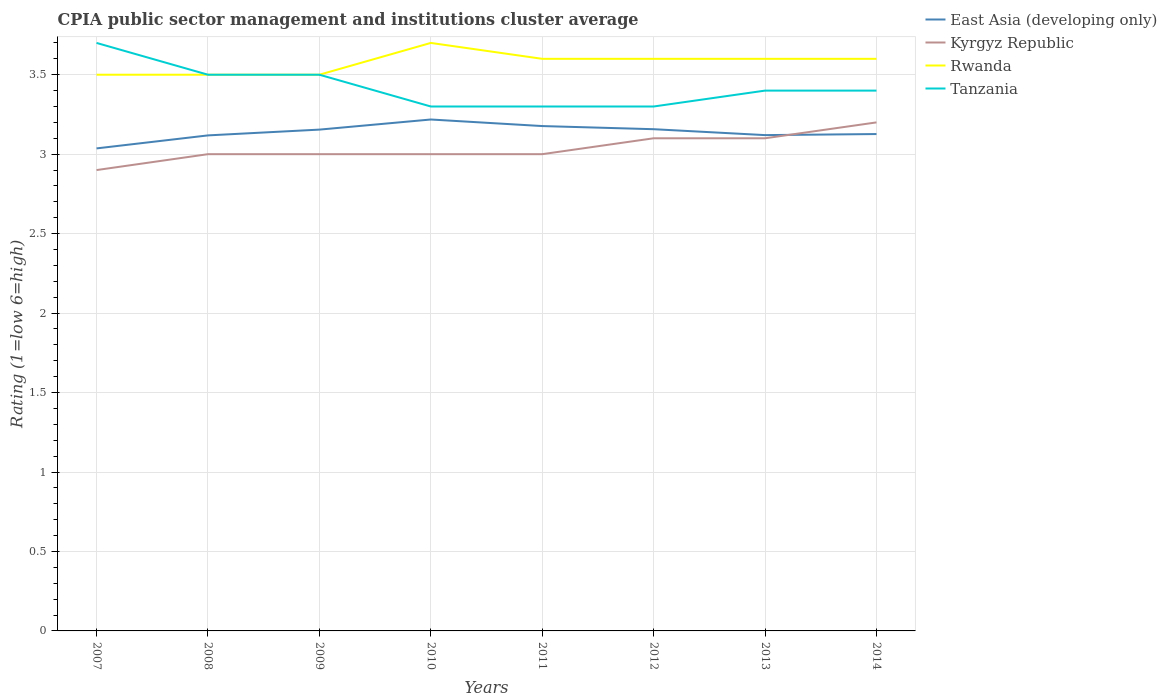Across all years, what is the maximum CPIA rating in Kyrgyz Republic?
Provide a short and direct response. 2.9. What is the total CPIA rating in Rwanda in the graph?
Offer a terse response. -0.1. What is the difference between the highest and the second highest CPIA rating in Rwanda?
Provide a short and direct response. 0.2. Is the CPIA rating in Tanzania strictly greater than the CPIA rating in Rwanda over the years?
Offer a very short reply. No. How many years are there in the graph?
Provide a succinct answer. 8. Are the values on the major ticks of Y-axis written in scientific E-notation?
Offer a terse response. No. Does the graph contain any zero values?
Your response must be concise. No. Does the graph contain grids?
Offer a terse response. Yes. How many legend labels are there?
Your answer should be very brief. 4. What is the title of the graph?
Ensure brevity in your answer.  CPIA public sector management and institutions cluster average. Does "Dominica" appear as one of the legend labels in the graph?
Ensure brevity in your answer.  No. What is the Rating (1=low 6=high) in East Asia (developing only) in 2007?
Give a very brief answer. 3.04. What is the Rating (1=low 6=high) of East Asia (developing only) in 2008?
Your answer should be compact. 3.12. What is the Rating (1=low 6=high) of Tanzania in 2008?
Make the answer very short. 3.5. What is the Rating (1=low 6=high) in East Asia (developing only) in 2009?
Ensure brevity in your answer.  3.15. What is the Rating (1=low 6=high) in Kyrgyz Republic in 2009?
Your response must be concise. 3. What is the Rating (1=low 6=high) in Rwanda in 2009?
Your response must be concise. 3.5. What is the Rating (1=low 6=high) of East Asia (developing only) in 2010?
Give a very brief answer. 3.22. What is the Rating (1=low 6=high) of Kyrgyz Republic in 2010?
Make the answer very short. 3. What is the Rating (1=low 6=high) of Tanzania in 2010?
Keep it short and to the point. 3.3. What is the Rating (1=low 6=high) in East Asia (developing only) in 2011?
Ensure brevity in your answer.  3.18. What is the Rating (1=low 6=high) of Rwanda in 2011?
Your answer should be very brief. 3.6. What is the Rating (1=low 6=high) of East Asia (developing only) in 2012?
Ensure brevity in your answer.  3.16. What is the Rating (1=low 6=high) in Kyrgyz Republic in 2012?
Ensure brevity in your answer.  3.1. What is the Rating (1=low 6=high) of East Asia (developing only) in 2013?
Your response must be concise. 3.12. What is the Rating (1=low 6=high) in East Asia (developing only) in 2014?
Provide a short and direct response. 3.13. What is the Rating (1=low 6=high) of Rwanda in 2014?
Provide a short and direct response. 3.6. Across all years, what is the maximum Rating (1=low 6=high) of East Asia (developing only)?
Give a very brief answer. 3.22. Across all years, what is the maximum Rating (1=low 6=high) in Kyrgyz Republic?
Your response must be concise. 3.2. Across all years, what is the maximum Rating (1=low 6=high) in Rwanda?
Keep it short and to the point. 3.7. Across all years, what is the minimum Rating (1=low 6=high) of East Asia (developing only)?
Provide a short and direct response. 3.04. Across all years, what is the minimum Rating (1=low 6=high) of Kyrgyz Republic?
Provide a succinct answer. 2.9. What is the total Rating (1=low 6=high) in East Asia (developing only) in the graph?
Keep it short and to the point. 25.11. What is the total Rating (1=low 6=high) of Kyrgyz Republic in the graph?
Make the answer very short. 24.3. What is the total Rating (1=low 6=high) in Rwanda in the graph?
Give a very brief answer. 28.6. What is the total Rating (1=low 6=high) of Tanzania in the graph?
Ensure brevity in your answer.  27.4. What is the difference between the Rating (1=low 6=high) of East Asia (developing only) in 2007 and that in 2008?
Offer a terse response. -0.08. What is the difference between the Rating (1=low 6=high) of Rwanda in 2007 and that in 2008?
Your answer should be compact. 0. What is the difference between the Rating (1=low 6=high) of Tanzania in 2007 and that in 2008?
Give a very brief answer. 0.2. What is the difference between the Rating (1=low 6=high) of East Asia (developing only) in 2007 and that in 2009?
Your answer should be very brief. -0.12. What is the difference between the Rating (1=low 6=high) in Kyrgyz Republic in 2007 and that in 2009?
Make the answer very short. -0.1. What is the difference between the Rating (1=low 6=high) of Rwanda in 2007 and that in 2009?
Make the answer very short. 0. What is the difference between the Rating (1=low 6=high) in East Asia (developing only) in 2007 and that in 2010?
Your answer should be compact. -0.18. What is the difference between the Rating (1=low 6=high) in Tanzania in 2007 and that in 2010?
Provide a succinct answer. 0.4. What is the difference between the Rating (1=low 6=high) in East Asia (developing only) in 2007 and that in 2011?
Your answer should be compact. -0.14. What is the difference between the Rating (1=low 6=high) in Kyrgyz Republic in 2007 and that in 2011?
Give a very brief answer. -0.1. What is the difference between the Rating (1=low 6=high) in Rwanda in 2007 and that in 2011?
Provide a succinct answer. -0.1. What is the difference between the Rating (1=low 6=high) in Tanzania in 2007 and that in 2011?
Make the answer very short. 0.4. What is the difference between the Rating (1=low 6=high) of East Asia (developing only) in 2007 and that in 2012?
Provide a short and direct response. -0.12. What is the difference between the Rating (1=low 6=high) of East Asia (developing only) in 2007 and that in 2013?
Offer a terse response. -0.08. What is the difference between the Rating (1=low 6=high) of Kyrgyz Republic in 2007 and that in 2013?
Your response must be concise. -0.2. What is the difference between the Rating (1=low 6=high) of East Asia (developing only) in 2007 and that in 2014?
Make the answer very short. -0.09. What is the difference between the Rating (1=low 6=high) of Tanzania in 2007 and that in 2014?
Your response must be concise. 0.3. What is the difference between the Rating (1=low 6=high) in East Asia (developing only) in 2008 and that in 2009?
Your answer should be very brief. -0.04. What is the difference between the Rating (1=low 6=high) of Tanzania in 2008 and that in 2009?
Provide a short and direct response. 0. What is the difference between the Rating (1=low 6=high) in East Asia (developing only) in 2008 and that in 2010?
Make the answer very short. -0.1. What is the difference between the Rating (1=low 6=high) of East Asia (developing only) in 2008 and that in 2011?
Provide a short and direct response. -0.06. What is the difference between the Rating (1=low 6=high) in Kyrgyz Republic in 2008 and that in 2011?
Make the answer very short. 0. What is the difference between the Rating (1=low 6=high) in Tanzania in 2008 and that in 2011?
Your response must be concise. 0.2. What is the difference between the Rating (1=low 6=high) of East Asia (developing only) in 2008 and that in 2012?
Keep it short and to the point. -0.04. What is the difference between the Rating (1=low 6=high) in Tanzania in 2008 and that in 2012?
Ensure brevity in your answer.  0.2. What is the difference between the Rating (1=low 6=high) in East Asia (developing only) in 2008 and that in 2013?
Your answer should be compact. -0. What is the difference between the Rating (1=low 6=high) of Kyrgyz Republic in 2008 and that in 2013?
Your response must be concise. -0.1. What is the difference between the Rating (1=low 6=high) of Tanzania in 2008 and that in 2013?
Offer a very short reply. 0.1. What is the difference between the Rating (1=low 6=high) in East Asia (developing only) in 2008 and that in 2014?
Your answer should be compact. -0.01. What is the difference between the Rating (1=low 6=high) in Kyrgyz Republic in 2008 and that in 2014?
Offer a terse response. -0.2. What is the difference between the Rating (1=low 6=high) of East Asia (developing only) in 2009 and that in 2010?
Your response must be concise. -0.06. What is the difference between the Rating (1=low 6=high) in Rwanda in 2009 and that in 2010?
Give a very brief answer. -0.2. What is the difference between the Rating (1=low 6=high) of East Asia (developing only) in 2009 and that in 2011?
Make the answer very short. -0.02. What is the difference between the Rating (1=low 6=high) in East Asia (developing only) in 2009 and that in 2012?
Provide a succinct answer. -0. What is the difference between the Rating (1=low 6=high) in Kyrgyz Republic in 2009 and that in 2012?
Provide a succinct answer. -0.1. What is the difference between the Rating (1=low 6=high) in East Asia (developing only) in 2009 and that in 2013?
Offer a terse response. 0.03. What is the difference between the Rating (1=low 6=high) of Kyrgyz Republic in 2009 and that in 2013?
Give a very brief answer. -0.1. What is the difference between the Rating (1=low 6=high) in East Asia (developing only) in 2009 and that in 2014?
Give a very brief answer. 0.03. What is the difference between the Rating (1=low 6=high) of East Asia (developing only) in 2010 and that in 2011?
Provide a succinct answer. 0.04. What is the difference between the Rating (1=low 6=high) in Kyrgyz Republic in 2010 and that in 2011?
Provide a succinct answer. 0. What is the difference between the Rating (1=low 6=high) in East Asia (developing only) in 2010 and that in 2012?
Offer a very short reply. 0.06. What is the difference between the Rating (1=low 6=high) in East Asia (developing only) in 2010 and that in 2013?
Provide a short and direct response. 0.1. What is the difference between the Rating (1=low 6=high) in Kyrgyz Republic in 2010 and that in 2013?
Keep it short and to the point. -0.1. What is the difference between the Rating (1=low 6=high) of Rwanda in 2010 and that in 2013?
Offer a very short reply. 0.1. What is the difference between the Rating (1=low 6=high) in East Asia (developing only) in 2010 and that in 2014?
Make the answer very short. 0.09. What is the difference between the Rating (1=low 6=high) in Rwanda in 2010 and that in 2014?
Ensure brevity in your answer.  0.1. What is the difference between the Rating (1=low 6=high) in East Asia (developing only) in 2011 and that in 2012?
Give a very brief answer. 0.02. What is the difference between the Rating (1=low 6=high) of Rwanda in 2011 and that in 2012?
Ensure brevity in your answer.  0. What is the difference between the Rating (1=low 6=high) in East Asia (developing only) in 2011 and that in 2013?
Keep it short and to the point. 0.06. What is the difference between the Rating (1=low 6=high) in Kyrgyz Republic in 2011 and that in 2013?
Offer a terse response. -0.1. What is the difference between the Rating (1=low 6=high) of East Asia (developing only) in 2011 and that in 2014?
Your answer should be compact. 0.05. What is the difference between the Rating (1=low 6=high) of Kyrgyz Republic in 2011 and that in 2014?
Your response must be concise. -0.2. What is the difference between the Rating (1=low 6=high) of Tanzania in 2011 and that in 2014?
Your answer should be compact. -0.1. What is the difference between the Rating (1=low 6=high) of East Asia (developing only) in 2012 and that in 2013?
Keep it short and to the point. 0.04. What is the difference between the Rating (1=low 6=high) of Kyrgyz Republic in 2012 and that in 2013?
Give a very brief answer. 0. What is the difference between the Rating (1=low 6=high) of Rwanda in 2012 and that in 2013?
Make the answer very short. 0. What is the difference between the Rating (1=low 6=high) of Tanzania in 2012 and that in 2013?
Ensure brevity in your answer.  -0.1. What is the difference between the Rating (1=low 6=high) in East Asia (developing only) in 2012 and that in 2014?
Your answer should be compact. 0.03. What is the difference between the Rating (1=low 6=high) of Tanzania in 2012 and that in 2014?
Your answer should be compact. -0.1. What is the difference between the Rating (1=low 6=high) in East Asia (developing only) in 2013 and that in 2014?
Keep it short and to the point. -0.01. What is the difference between the Rating (1=low 6=high) of Kyrgyz Republic in 2013 and that in 2014?
Keep it short and to the point. -0.1. What is the difference between the Rating (1=low 6=high) in Rwanda in 2013 and that in 2014?
Your response must be concise. 0. What is the difference between the Rating (1=low 6=high) in Tanzania in 2013 and that in 2014?
Keep it short and to the point. 0. What is the difference between the Rating (1=low 6=high) of East Asia (developing only) in 2007 and the Rating (1=low 6=high) of Kyrgyz Republic in 2008?
Make the answer very short. 0.04. What is the difference between the Rating (1=low 6=high) in East Asia (developing only) in 2007 and the Rating (1=low 6=high) in Rwanda in 2008?
Make the answer very short. -0.46. What is the difference between the Rating (1=low 6=high) of East Asia (developing only) in 2007 and the Rating (1=low 6=high) of Tanzania in 2008?
Ensure brevity in your answer.  -0.46. What is the difference between the Rating (1=low 6=high) in Kyrgyz Republic in 2007 and the Rating (1=low 6=high) in Tanzania in 2008?
Your answer should be compact. -0.6. What is the difference between the Rating (1=low 6=high) in Rwanda in 2007 and the Rating (1=low 6=high) in Tanzania in 2008?
Make the answer very short. 0. What is the difference between the Rating (1=low 6=high) of East Asia (developing only) in 2007 and the Rating (1=low 6=high) of Kyrgyz Republic in 2009?
Your answer should be compact. 0.04. What is the difference between the Rating (1=low 6=high) of East Asia (developing only) in 2007 and the Rating (1=low 6=high) of Rwanda in 2009?
Make the answer very short. -0.46. What is the difference between the Rating (1=low 6=high) of East Asia (developing only) in 2007 and the Rating (1=low 6=high) of Tanzania in 2009?
Provide a succinct answer. -0.46. What is the difference between the Rating (1=low 6=high) in Kyrgyz Republic in 2007 and the Rating (1=low 6=high) in Rwanda in 2009?
Provide a succinct answer. -0.6. What is the difference between the Rating (1=low 6=high) in Kyrgyz Republic in 2007 and the Rating (1=low 6=high) in Tanzania in 2009?
Ensure brevity in your answer.  -0.6. What is the difference between the Rating (1=low 6=high) in Rwanda in 2007 and the Rating (1=low 6=high) in Tanzania in 2009?
Offer a terse response. 0. What is the difference between the Rating (1=low 6=high) of East Asia (developing only) in 2007 and the Rating (1=low 6=high) of Kyrgyz Republic in 2010?
Keep it short and to the point. 0.04. What is the difference between the Rating (1=low 6=high) of East Asia (developing only) in 2007 and the Rating (1=low 6=high) of Rwanda in 2010?
Provide a succinct answer. -0.66. What is the difference between the Rating (1=low 6=high) in East Asia (developing only) in 2007 and the Rating (1=low 6=high) in Tanzania in 2010?
Provide a short and direct response. -0.26. What is the difference between the Rating (1=low 6=high) in East Asia (developing only) in 2007 and the Rating (1=low 6=high) in Kyrgyz Republic in 2011?
Provide a succinct answer. 0.04. What is the difference between the Rating (1=low 6=high) in East Asia (developing only) in 2007 and the Rating (1=low 6=high) in Rwanda in 2011?
Offer a very short reply. -0.56. What is the difference between the Rating (1=low 6=high) of East Asia (developing only) in 2007 and the Rating (1=low 6=high) of Tanzania in 2011?
Provide a short and direct response. -0.26. What is the difference between the Rating (1=low 6=high) of Kyrgyz Republic in 2007 and the Rating (1=low 6=high) of Rwanda in 2011?
Keep it short and to the point. -0.7. What is the difference between the Rating (1=low 6=high) of Rwanda in 2007 and the Rating (1=low 6=high) of Tanzania in 2011?
Offer a very short reply. 0.2. What is the difference between the Rating (1=low 6=high) of East Asia (developing only) in 2007 and the Rating (1=low 6=high) of Kyrgyz Republic in 2012?
Your response must be concise. -0.06. What is the difference between the Rating (1=low 6=high) of East Asia (developing only) in 2007 and the Rating (1=low 6=high) of Rwanda in 2012?
Give a very brief answer. -0.56. What is the difference between the Rating (1=low 6=high) in East Asia (developing only) in 2007 and the Rating (1=low 6=high) in Tanzania in 2012?
Offer a terse response. -0.26. What is the difference between the Rating (1=low 6=high) in Kyrgyz Republic in 2007 and the Rating (1=low 6=high) in Rwanda in 2012?
Your answer should be compact. -0.7. What is the difference between the Rating (1=low 6=high) in Kyrgyz Republic in 2007 and the Rating (1=low 6=high) in Tanzania in 2012?
Offer a terse response. -0.4. What is the difference between the Rating (1=low 6=high) in East Asia (developing only) in 2007 and the Rating (1=low 6=high) in Kyrgyz Republic in 2013?
Provide a succinct answer. -0.06. What is the difference between the Rating (1=low 6=high) in East Asia (developing only) in 2007 and the Rating (1=low 6=high) in Rwanda in 2013?
Give a very brief answer. -0.56. What is the difference between the Rating (1=low 6=high) in East Asia (developing only) in 2007 and the Rating (1=low 6=high) in Tanzania in 2013?
Keep it short and to the point. -0.36. What is the difference between the Rating (1=low 6=high) of Kyrgyz Republic in 2007 and the Rating (1=low 6=high) of Rwanda in 2013?
Your answer should be very brief. -0.7. What is the difference between the Rating (1=low 6=high) of East Asia (developing only) in 2007 and the Rating (1=low 6=high) of Kyrgyz Republic in 2014?
Offer a terse response. -0.16. What is the difference between the Rating (1=low 6=high) of East Asia (developing only) in 2007 and the Rating (1=low 6=high) of Rwanda in 2014?
Offer a very short reply. -0.56. What is the difference between the Rating (1=low 6=high) of East Asia (developing only) in 2007 and the Rating (1=low 6=high) of Tanzania in 2014?
Keep it short and to the point. -0.36. What is the difference between the Rating (1=low 6=high) in East Asia (developing only) in 2008 and the Rating (1=low 6=high) in Kyrgyz Republic in 2009?
Offer a terse response. 0.12. What is the difference between the Rating (1=low 6=high) in East Asia (developing only) in 2008 and the Rating (1=low 6=high) in Rwanda in 2009?
Give a very brief answer. -0.38. What is the difference between the Rating (1=low 6=high) in East Asia (developing only) in 2008 and the Rating (1=low 6=high) in Tanzania in 2009?
Ensure brevity in your answer.  -0.38. What is the difference between the Rating (1=low 6=high) in Kyrgyz Republic in 2008 and the Rating (1=low 6=high) in Tanzania in 2009?
Offer a terse response. -0.5. What is the difference between the Rating (1=low 6=high) in Rwanda in 2008 and the Rating (1=low 6=high) in Tanzania in 2009?
Ensure brevity in your answer.  0. What is the difference between the Rating (1=low 6=high) of East Asia (developing only) in 2008 and the Rating (1=low 6=high) of Kyrgyz Republic in 2010?
Make the answer very short. 0.12. What is the difference between the Rating (1=low 6=high) of East Asia (developing only) in 2008 and the Rating (1=low 6=high) of Rwanda in 2010?
Keep it short and to the point. -0.58. What is the difference between the Rating (1=low 6=high) of East Asia (developing only) in 2008 and the Rating (1=low 6=high) of Tanzania in 2010?
Offer a terse response. -0.18. What is the difference between the Rating (1=low 6=high) in Kyrgyz Republic in 2008 and the Rating (1=low 6=high) in Rwanda in 2010?
Provide a succinct answer. -0.7. What is the difference between the Rating (1=low 6=high) in Kyrgyz Republic in 2008 and the Rating (1=low 6=high) in Tanzania in 2010?
Offer a very short reply. -0.3. What is the difference between the Rating (1=low 6=high) of East Asia (developing only) in 2008 and the Rating (1=low 6=high) of Kyrgyz Republic in 2011?
Keep it short and to the point. 0.12. What is the difference between the Rating (1=low 6=high) in East Asia (developing only) in 2008 and the Rating (1=low 6=high) in Rwanda in 2011?
Provide a succinct answer. -0.48. What is the difference between the Rating (1=low 6=high) of East Asia (developing only) in 2008 and the Rating (1=low 6=high) of Tanzania in 2011?
Provide a short and direct response. -0.18. What is the difference between the Rating (1=low 6=high) of Kyrgyz Republic in 2008 and the Rating (1=low 6=high) of Rwanda in 2011?
Offer a very short reply. -0.6. What is the difference between the Rating (1=low 6=high) of Rwanda in 2008 and the Rating (1=low 6=high) of Tanzania in 2011?
Ensure brevity in your answer.  0.2. What is the difference between the Rating (1=low 6=high) of East Asia (developing only) in 2008 and the Rating (1=low 6=high) of Kyrgyz Republic in 2012?
Offer a very short reply. 0.02. What is the difference between the Rating (1=low 6=high) in East Asia (developing only) in 2008 and the Rating (1=low 6=high) in Rwanda in 2012?
Keep it short and to the point. -0.48. What is the difference between the Rating (1=low 6=high) of East Asia (developing only) in 2008 and the Rating (1=low 6=high) of Tanzania in 2012?
Provide a succinct answer. -0.18. What is the difference between the Rating (1=low 6=high) of Kyrgyz Republic in 2008 and the Rating (1=low 6=high) of Tanzania in 2012?
Provide a succinct answer. -0.3. What is the difference between the Rating (1=low 6=high) of Rwanda in 2008 and the Rating (1=low 6=high) of Tanzania in 2012?
Provide a short and direct response. 0.2. What is the difference between the Rating (1=low 6=high) of East Asia (developing only) in 2008 and the Rating (1=low 6=high) of Kyrgyz Republic in 2013?
Your answer should be compact. 0.02. What is the difference between the Rating (1=low 6=high) in East Asia (developing only) in 2008 and the Rating (1=low 6=high) in Rwanda in 2013?
Provide a succinct answer. -0.48. What is the difference between the Rating (1=low 6=high) of East Asia (developing only) in 2008 and the Rating (1=low 6=high) of Tanzania in 2013?
Give a very brief answer. -0.28. What is the difference between the Rating (1=low 6=high) in Kyrgyz Republic in 2008 and the Rating (1=low 6=high) in Rwanda in 2013?
Offer a terse response. -0.6. What is the difference between the Rating (1=low 6=high) of Kyrgyz Republic in 2008 and the Rating (1=low 6=high) of Tanzania in 2013?
Your answer should be very brief. -0.4. What is the difference between the Rating (1=low 6=high) in East Asia (developing only) in 2008 and the Rating (1=low 6=high) in Kyrgyz Republic in 2014?
Your response must be concise. -0.08. What is the difference between the Rating (1=low 6=high) in East Asia (developing only) in 2008 and the Rating (1=low 6=high) in Rwanda in 2014?
Your answer should be very brief. -0.48. What is the difference between the Rating (1=low 6=high) in East Asia (developing only) in 2008 and the Rating (1=low 6=high) in Tanzania in 2014?
Ensure brevity in your answer.  -0.28. What is the difference between the Rating (1=low 6=high) of Kyrgyz Republic in 2008 and the Rating (1=low 6=high) of Rwanda in 2014?
Ensure brevity in your answer.  -0.6. What is the difference between the Rating (1=low 6=high) of East Asia (developing only) in 2009 and the Rating (1=low 6=high) of Kyrgyz Republic in 2010?
Your response must be concise. 0.15. What is the difference between the Rating (1=low 6=high) of East Asia (developing only) in 2009 and the Rating (1=low 6=high) of Rwanda in 2010?
Make the answer very short. -0.55. What is the difference between the Rating (1=low 6=high) in East Asia (developing only) in 2009 and the Rating (1=low 6=high) in Tanzania in 2010?
Offer a very short reply. -0.15. What is the difference between the Rating (1=low 6=high) in Kyrgyz Republic in 2009 and the Rating (1=low 6=high) in Rwanda in 2010?
Offer a terse response. -0.7. What is the difference between the Rating (1=low 6=high) in East Asia (developing only) in 2009 and the Rating (1=low 6=high) in Kyrgyz Republic in 2011?
Your response must be concise. 0.15. What is the difference between the Rating (1=low 6=high) in East Asia (developing only) in 2009 and the Rating (1=low 6=high) in Rwanda in 2011?
Your answer should be compact. -0.45. What is the difference between the Rating (1=low 6=high) of East Asia (developing only) in 2009 and the Rating (1=low 6=high) of Tanzania in 2011?
Keep it short and to the point. -0.15. What is the difference between the Rating (1=low 6=high) of Rwanda in 2009 and the Rating (1=low 6=high) of Tanzania in 2011?
Give a very brief answer. 0.2. What is the difference between the Rating (1=low 6=high) of East Asia (developing only) in 2009 and the Rating (1=low 6=high) of Kyrgyz Republic in 2012?
Give a very brief answer. 0.05. What is the difference between the Rating (1=low 6=high) of East Asia (developing only) in 2009 and the Rating (1=low 6=high) of Rwanda in 2012?
Ensure brevity in your answer.  -0.45. What is the difference between the Rating (1=low 6=high) in East Asia (developing only) in 2009 and the Rating (1=low 6=high) in Tanzania in 2012?
Keep it short and to the point. -0.15. What is the difference between the Rating (1=low 6=high) in Rwanda in 2009 and the Rating (1=low 6=high) in Tanzania in 2012?
Your response must be concise. 0.2. What is the difference between the Rating (1=low 6=high) in East Asia (developing only) in 2009 and the Rating (1=low 6=high) in Kyrgyz Republic in 2013?
Ensure brevity in your answer.  0.05. What is the difference between the Rating (1=low 6=high) in East Asia (developing only) in 2009 and the Rating (1=low 6=high) in Rwanda in 2013?
Provide a succinct answer. -0.45. What is the difference between the Rating (1=low 6=high) of East Asia (developing only) in 2009 and the Rating (1=low 6=high) of Tanzania in 2013?
Offer a terse response. -0.25. What is the difference between the Rating (1=low 6=high) of Kyrgyz Republic in 2009 and the Rating (1=low 6=high) of Rwanda in 2013?
Your answer should be very brief. -0.6. What is the difference between the Rating (1=low 6=high) of East Asia (developing only) in 2009 and the Rating (1=low 6=high) of Kyrgyz Republic in 2014?
Offer a very short reply. -0.05. What is the difference between the Rating (1=low 6=high) of East Asia (developing only) in 2009 and the Rating (1=low 6=high) of Rwanda in 2014?
Offer a terse response. -0.45. What is the difference between the Rating (1=low 6=high) in East Asia (developing only) in 2009 and the Rating (1=low 6=high) in Tanzania in 2014?
Make the answer very short. -0.25. What is the difference between the Rating (1=low 6=high) of Kyrgyz Republic in 2009 and the Rating (1=low 6=high) of Rwanda in 2014?
Give a very brief answer. -0.6. What is the difference between the Rating (1=low 6=high) of Kyrgyz Republic in 2009 and the Rating (1=low 6=high) of Tanzania in 2014?
Provide a short and direct response. -0.4. What is the difference between the Rating (1=low 6=high) in East Asia (developing only) in 2010 and the Rating (1=low 6=high) in Kyrgyz Republic in 2011?
Keep it short and to the point. 0.22. What is the difference between the Rating (1=low 6=high) of East Asia (developing only) in 2010 and the Rating (1=low 6=high) of Rwanda in 2011?
Ensure brevity in your answer.  -0.38. What is the difference between the Rating (1=low 6=high) of East Asia (developing only) in 2010 and the Rating (1=low 6=high) of Tanzania in 2011?
Give a very brief answer. -0.08. What is the difference between the Rating (1=low 6=high) of Kyrgyz Republic in 2010 and the Rating (1=low 6=high) of Rwanda in 2011?
Offer a terse response. -0.6. What is the difference between the Rating (1=low 6=high) of Rwanda in 2010 and the Rating (1=low 6=high) of Tanzania in 2011?
Ensure brevity in your answer.  0.4. What is the difference between the Rating (1=low 6=high) of East Asia (developing only) in 2010 and the Rating (1=low 6=high) of Kyrgyz Republic in 2012?
Offer a very short reply. 0.12. What is the difference between the Rating (1=low 6=high) of East Asia (developing only) in 2010 and the Rating (1=low 6=high) of Rwanda in 2012?
Ensure brevity in your answer.  -0.38. What is the difference between the Rating (1=low 6=high) of East Asia (developing only) in 2010 and the Rating (1=low 6=high) of Tanzania in 2012?
Ensure brevity in your answer.  -0.08. What is the difference between the Rating (1=low 6=high) of Kyrgyz Republic in 2010 and the Rating (1=low 6=high) of Rwanda in 2012?
Provide a short and direct response. -0.6. What is the difference between the Rating (1=low 6=high) in Rwanda in 2010 and the Rating (1=low 6=high) in Tanzania in 2012?
Keep it short and to the point. 0.4. What is the difference between the Rating (1=low 6=high) of East Asia (developing only) in 2010 and the Rating (1=low 6=high) of Kyrgyz Republic in 2013?
Provide a succinct answer. 0.12. What is the difference between the Rating (1=low 6=high) of East Asia (developing only) in 2010 and the Rating (1=low 6=high) of Rwanda in 2013?
Make the answer very short. -0.38. What is the difference between the Rating (1=low 6=high) of East Asia (developing only) in 2010 and the Rating (1=low 6=high) of Tanzania in 2013?
Provide a short and direct response. -0.18. What is the difference between the Rating (1=low 6=high) of Kyrgyz Republic in 2010 and the Rating (1=low 6=high) of Rwanda in 2013?
Ensure brevity in your answer.  -0.6. What is the difference between the Rating (1=low 6=high) in East Asia (developing only) in 2010 and the Rating (1=low 6=high) in Kyrgyz Republic in 2014?
Keep it short and to the point. 0.02. What is the difference between the Rating (1=low 6=high) in East Asia (developing only) in 2010 and the Rating (1=low 6=high) in Rwanda in 2014?
Offer a very short reply. -0.38. What is the difference between the Rating (1=low 6=high) of East Asia (developing only) in 2010 and the Rating (1=low 6=high) of Tanzania in 2014?
Your answer should be very brief. -0.18. What is the difference between the Rating (1=low 6=high) in Kyrgyz Republic in 2010 and the Rating (1=low 6=high) in Rwanda in 2014?
Your answer should be very brief. -0.6. What is the difference between the Rating (1=low 6=high) in Rwanda in 2010 and the Rating (1=low 6=high) in Tanzania in 2014?
Your answer should be compact. 0.3. What is the difference between the Rating (1=low 6=high) of East Asia (developing only) in 2011 and the Rating (1=low 6=high) of Kyrgyz Republic in 2012?
Make the answer very short. 0.08. What is the difference between the Rating (1=low 6=high) in East Asia (developing only) in 2011 and the Rating (1=low 6=high) in Rwanda in 2012?
Your answer should be compact. -0.42. What is the difference between the Rating (1=low 6=high) in East Asia (developing only) in 2011 and the Rating (1=low 6=high) in Tanzania in 2012?
Keep it short and to the point. -0.12. What is the difference between the Rating (1=low 6=high) in East Asia (developing only) in 2011 and the Rating (1=low 6=high) in Kyrgyz Republic in 2013?
Your answer should be very brief. 0.08. What is the difference between the Rating (1=low 6=high) of East Asia (developing only) in 2011 and the Rating (1=low 6=high) of Rwanda in 2013?
Provide a short and direct response. -0.42. What is the difference between the Rating (1=low 6=high) in East Asia (developing only) in 2011 and the Rating (1=low 6=high) in Tanzania in 2013?
Give a very brief answer. -0.22. What is the difference between the Rating (1=low 6=high) of Kyrgyz Republic in 2011 and the Rating (1=low 6=high) of Rwanda in 2013?
Offer a very short reply. -0.6. What is the difference between the Rating (1=low 6=high) of Kyrgyz Republic in 2011 and the Rating (1=low 6=high) of Tanzania in 2013?
Provide a succinct answer. -0.4. What is the difference between the Rating (1=low 6=high) in East Asia (developing only) in 2011 and the Rating (1=low 6=high) in Kyrgyz Republic in 2014?
Give a very brief answer. -0.02. What is the difference between the Rating (1=low 6=high) of East Asia (developing only) in 2011 and the Rating (1=low 6=high) of Rwanda in 2014?
Ensure brevity in your answer.  -0.42. What is the difference between the Rating (1=low 6=high) in East Asia (developing only) in 2011 and the Rating (1=low 6=high) in Tanzania in 2014?
Provide a succinct answer. -0.22. What is the difference between the Rating (1=low 6=high) in Rwanda in 2011 and the Rating (1=low 6=high) in Tanzania in 2014?
Give a very brief answer. 0.2. What is the difference between the Rating (1=low 6=high) of East Asia (developing only) in 2012 and the Rating (1=low 6=high) of Kyrgyz Republic in 2013?
Provide a succinct answer. 0.06. What is the difference between the Rating (1=low 6=high) of East Asia (developing only) in 2012 and the Rating (1=low 6=high) of Rwanda in 2013?
Offer a terse response. -0.44. What is the difference between the Rating (1=low 6=high) of East Asia (developing only) in 2012 and the Rating (1=low 6=high) of Tanzania in 2013?
Offer a very short reply. -0.24. What is the difference between the Rating (1=low 6=high) of Rwanda in 2012 and the Rating (1=low 6=high) of Tanzania in 2013?
Offer a terse response. 0.2. What is the difference between the Rating (1=low 6=high) of East Asia (developing only) in 2012 and the Rating (1=low 6=high) of Kyrgyz Republic in 2014?
Make the answer very short. -0.04. What is the difference between the Rating (1=low 6=high) of East Asia (developing only) in 2012 and the Rating (1=low 6=high) of Rwanda in 2014?
Keep it short and to the point. -0.44. What is the difference between the Rating (1=low 6=high) of East Asia (developing only) in 2012 and the Rating (1=low 6=high) of Tanzania in 2014?
Give a very brief answer. -0.24. What is the difference between the Rating (1=low 6=high) in Kyrgyz Republic in 2012 and the Rating (1=low 6=high) in Rwanda in 2014?
Provide a short and direct response. -0.5. What is the difference between the Rating (1=low 6=high) in East Asia (developing only) in 2013 and the Rating (1=low 6=high) in Kyrgyz Republic in 2014?
Make the answer very short. -0.08. What is the difference between the Rating (1=low 6=high) of East Asia (developing only) in 2013 and the Rating (1=low 6=high) of Rwanda in 2014?
Offer a terse response. -0.48. What is the difference between the Rating (1=low 6=high) in East Asia (developing only) in 2013 and the Rating (1=low 6=high) in Tanzania in 2014?
Provide a succinct answer. -0.28. What is the difference between the Rating (1=low 6=high) of Rwanda in 2013 and the Rating (1=low 6=high) of Tanzania in 2014?
Your response must be concise. 0.2. What is the average Rating (1=low 6=high) of East Asia (developing only) per year?
Give a very brief answer. 3.14. What is the average Rating (1=low 6=high) in Kyrgyz Republic per year?
Your answer should be compact. 3.04. What is the average Rating (1=low 6=high) in Rwanda per year?
Provide a short and direct response. 3.58. What is the average Rating (1=low 6=high) in Tanzania per year?
Keep it short and to the point. 3.42. In the year 2007, what is the difference between the Rating (1=low 6=high) in East Asia (developing only) and Rating (1=low 6=high) in Kyrgyz Republic?
Provide a succinct answer. 0.14. In the year 2007, what is the difference between the Rating (1=low 6=high) in East Asia (developing only) and Rating (1=low 6=high) in Rwanda?
Your answer should be very brief. -0.46. In the year 2007, what is the difference between the Rating (1=low 6=high) of East Asia (developing only) and Rating (1=low 6=high) of Tanzania?
Ensure brevity in your answer.  -0.66. In the year 2007, what is the difference between the Rating (1=low 6=high) of Rwanda and Rating (1=low 6=high) of Tanzania?
Your answer should be compact. -0.2. In the year 2008, what is the difference between the Rating (1=low 6=high) in East Asia (developing only) and Rating (1=low 6=high) in Kyrgyz Republic?
Provide a succinct answer. 0.12. In the year 2008, what is the difference between the Rating (1=low 6=high) in East Asia (developing only) and Rating (1=low 6=high) in Rwanda?
Provide a short and direct response. -0.38. In the year 2008, what is the difference between the Rating (1=low 6=high) of East Asia (developing only) and Rating (1=low 6=high) of Tanzania?
Provide a short and direct response. -0.38. In the year 2008, what is the difference between the Rating (1=low 6=high) of Kyrgyz Republic and Rating (1=low 6=high) of Rwanda?
Your answer should be compact. -0.5. In the year 2009, what is the difference between the Rating (1=low 6=high) of East Asia (developing only) and Rating (1=low 6=high) of Kyrgyz Republic?
Your response must be concise. 0.15. In the year 2009, what is the difference between the Rating (1=low 6=high) of East Asia (developing only) and Rating (1=low 6=high) of Rwanda?
Offer a terse response. -0.35. In the year 2009, what is the difference between the Rating (1=low 6=high) of East Asia (developing only) and Rating (1=low 6=high) of Tanzania?
Ensure brevity in your answer.  -0.35. In the year 2009, what is the difference between the Rating (1=low 6=high) in Kyrgyz Republic and Rating (1=low 6=high) in Rwanda?
Keep it short and to the point. -0.5. In the year 2009, what is the difference between the Rating (1=low 6=high) in Rwanda and Rating (1=low 6=high) in Tanzania?
Keep it short and to the point. 0. In the year 2010, what is the difference between the Rating (1=low 6=high) in East Asia (developing only) and Rating (1=low 6=high) in Kyrgyz Republic?
Provide a short and direct response. 0.22. In the year 2010, what is the difference between the Rating (1=low 6=high) in East Asia (developing only) and Rating (1=low 6=high) in Rwanda?
Your response must be concise. -0.48. In the year 2010, what is the difference between the Rating (1=low 6=high) of East Asia (developing only) and Rating (1=low 6=high) of Tanzania?
Give a very brief answer. -0.08. In the year 2010, what is the difference between the Rating (1=low 6=high) of Kyrgyz Republic and Rating (1=low 6=high) of Rwanda?
Your answer should be compact. -0.7. In the year 2010, what is the difference between the Rating (1=low 6=high) in Kyrgyz Republic and Rating (1=low 6=high) in Tanzania?
Offer a very short reply. -0.3. In the year 2011, what is the difference between the Rating (1=low 6=high) in East Asia (developing only) and Rating (1=low 6=high) in Kyrgyz Republic?
Ensure brevity in your answer.  0.18. In the year 2011, what is the difference between the Rating (1=low 6=high) in East Asia (developing only) and Rating (1=low 6=high) in Rwanda?
Make the answer very short. -0.42. In the year 2011, what is the difference between the Rating (1=low 6=high) of East Asia (developing only) and Rating (1=low 6=high) of Tanzania?
Provide a succinct answer. -0.12. In the year 2011, what is the difference between the Rating (1=low 6=high) of Kyrgyz Republic and Rating (1=low 6=high) of Rwanda?
Give a very brief answer. -0.6. In the year 2011, what is the difference between the Rating (1=low 6=high) of Rwanda and Rating (1=low 6=high) of Tanzania?
Offer a very short reply. 0.3. In the year 2012, what is the difference between the Rating (1=low 6=high) of East Asia (developing only) and Rating (1=low 6=high) of Kyrgyz Republic?
Your answer should be very brief. 0.06. In the year 2012, what is the difference between the Rating (1=low 6=high) in East Asia (developing only) and Rating (1=low 6=high) in Rwanda?
Your answer should be compact. -0.44. In the year 2012, what is the difference between the Rating (1=low 6=high) of East Asia (developing only) and Rating (1=low 6=high) of Tanzania?
Make the answer very short. -0.14. In the year 2012, what is the difference between the Rating (1=low 6=high) in Rwanda and Rating (1=low 6=high) in Tanzania?
Your answer should be very brief. 0.3. In the year 2013, what is the difference between the Rating (1=low 6=high) of East Asia (developing only) and Rating (1=low 6=high) of Rwanda?
Your response must be concise. -0.48. In the year 2013, what is the difference between the Rating (1=low 6=high) in East Asia (developing only) and Rating (1=low 6=high) in Tanzania?
Keep it short and to the point. -0.28. In the year 2013, what is the difference between the Rating (1=low 6=high) in Kyrgyz Republic and Rating (1=low 6=high) in Tanzania?
Your answer should be very brief. -0.3. In the year 2014, what is the difference between the Rating (1=low 6=high) in East Asia (developing only) and Rating (1=low 6=high) in Kyrgyz Republic?
Provide a short and direct response. -0.07. In the year 2014, what is the difference between the Rating (1=low 6=high) of East Asia (developing only) and Rating (1=low 6=high) of Rwanda?
Make the answer very short. -0.47. In the year 2014, what is the difference between the Rating (1=low 6=high) in East Asia (developing only) and Rating (1=low 6=high) in Tanzania?
Give a very brief answer. -0.27. In the year 2014, what is the difference between the Rating (1=low 6=high) of Kyrgyz Republic and Rating (1=low 6=high) of Rwanda?
Ensure brevity in your answer.  -0.4. In the year 2014, what is the difference between the Rating (1=low 6=high) in Rwanda and Rating (1=low 6=high) in Tanzania?
Offer a terse response. 0.2. What is the ratio of the Rating (1=low 6=high) of East Asia (developing only) in 2007 to that in 2008?
Give a very brief answer. 0.97. What is the ratio of the Rating (1=low 6=high) in Kyrgyz Republic in 2007 to that in 2008?
Provide a short and direct response. 0.97. What is the ratio of the Rating (1=low 6=high) of Rwanda in 2007 to that in 2008?
Offer a very short reply. 1. What is the ratio of the Rating (1=low 6=high) of Tanzania in 2007 to that in 2008?
Provide a short and direct response. 1.06. What is the ratio of the Rating (1=low 6=high) of East Asia (developing only) in 2007 to that in 2009?
Keep it short and to the point. 0.96. What is the ratio of the Rating (1=low 6=high) of Kyrgyz Republic in 2007 to that in 2009?
Offer a very short reply. 0.97. What is the ratio of the Rating (1=low 6=high) in Rwanda in 2007 to that in 2009?
Offer a very short reply. 1. What is the ratio of the Rating (1=low 6=high) in Tanzania in 2007 to that in 2009?
Make the answer very short. 1.06. What is the ratio of the Rating (1=low 6=high) in East Asia (developing only) in 2007 to that in 2010?
Your response must be concise. 0.94. What is the ratio of the Rating (1=low 6=high) in Kyrgyz Republic in 2007 to that in 2010?
Provide a succinct answer. 0.97. What is the ratio of the Rating (1=low 6=high) of Rwanda in 2007 to that in 2010?
Make the answer very short. 0.95. What is the ratio of the Rating (1=low 6=high) in Tanzania in 2007 to that in 2010?
Keep it short and to the point. 1.12. What is the ratio of the Rating (1=low 6=high) in East Asia (developing only) in 2007 to that in 2011?
Your response must be concise. 0.96. What is the ratio of the Rating (1=low 6=high) of Kyrgyz Republic in 2007 to that in 2011?
Offer a terse response. 0.97. What is the ratio of the Rating (1=low 6=high) of Rwanda in 2007 to that in 2011?
Make the answer very short. 0.97. What is the ratio of the Rating (1=low 6=high) in Tanzania in 2007 to that in 2011?
Provide a short and direct response. 1.12. What is the ratio of the Rating (1=low 6=high) in East Asia (developing only) in 2007 to that in 2012?
Your answer should be compact. 0.96. What is the ratio of the Rating (1=low 6=high) in Kyrgyz Republic in 2007 to that in 2012?
Provide a short and direct response. 0.94. What is the ratio of the Rating (1=low 6=high) of Rwanda in 2007 to that in 2012?
Make the answer very short. 0.97. What is the ratio of the Rating (1=low 6=high) of Tanzania in 2007 to that in 2012?
Ensure brevity in your answer.  1.12. What is the ratio of the Rating (1=low 6=high) in East Asia (developing only) in 2007 to that in 2013?
Ensure brevity in your answer.  0.97. What is the ratio of the Rating (1=low 6=high) in Kyrgyz Republic in 2007 to that in 2013?
Keep it short and to the point. 0.94. What is the ratio of the Rating (1=low 6=high) of Rwanda in 2007 to that in 2013?
Your response must be concise. 0.97. What is the ratio of the Rating (1=low 6=high) in Tanzania in 2007 to that in 2013?
Ensure brevity in your answer.  1.09. What is the ratio of the Rating (1=low 6=high) in East Asia (developing only) in 2007 to that in 2014?
Keep it short and to the point. 0.97. What is the ratio of the Rating (1=low 6=high) in Kyrgyz Republic in 2007 to that in 2014?
Make the answer very short. 0.91. What is the ratio of the Rating (1=low 6=high) in Rwanda in 2007 to that in 2014?
Provide a succinct answer. 0.97. What is the ratio of the Rating (1=low 6=high) of Tanzania in 2007 to that in 2014?
Your answer should be very brief. 1.09. What is the ratio of the Rating (1=low 6=high) in East Asia (developing only) in 2008 to that in 2010?
Ensure brevity in your answer.  0.97. What is the ratio of the Rating (1=low 6=high) of Rwanda in 2008 to that in 2010?
Ensure brevity in your answer.  0.95. What is the ratio of the Rating (1=low 6=high) of Tanzania in 2008 to that in 2010?
Ensure brevity in your answer.  1.06. What is the ratio of the Rating (1=low 6=high) in East Asia (developing only) in 2008 to that in 2011?
Ensure brevity in your answer.  0.98. What is the ratio of the Rating (1=low 6=high) of Kyrgyz Republic in 2008 to that in 2011?
Provide a short and direct response. 1. What is the ratio of the Rating (1=low 6=high) in Rwanda in 2008 to that in 2011?
Give a very brief answer. 0.97. What is the ratio of the Rating (1=low 6=high) in Tanzania in 2008 to that in 2011?
Offer a terse response. 1.06. What is the ratio of the Rating (1=low 6=high) in Kyrgyz Republic in 2008 to that in 2012?
Your response must be concise. 0.97. What is the ratio of the Rating (1=low 6=high) in Rwanda in 2008 to that in 2012?
Offer a very short reply. 0.97. What is the ratio of the Rating (1=low 6=high) of Tanzania in 2008 to that in 2012?
Keep it short and to the point. 1.06. What is the ratio of the Rating (1=low 6=high) of Rwanda in 2008 to that in 2013?
Your answer should be very brief. 0.97. What is the ratio of the Rating (1=low 6=high) of Tanzania in 2008 to that in 2013?
Give a very brief answer. 1.03. What is the ratio of the Rating (1=low 6=high) of Kyrgyz Republic in 2008 to that in 2014?
Keep it short and to the point. 0.94. What is the ratio of the Rating (1=low 6=high) in Rwanda in 2008 to that in 2014?
Ensure brevity in your answer.  0.97. What is the ratio of the Rating (1=low 6=high) in Tanzania in 2008 to that in 2014?
Make the answer very short. 1.03. What is the ratio of the Rating (1=low 6=high) in East Asia (developing only) in 2009 to that in 2010?
Make the answer very short. 0.98. What is the ratio of the Rating (1=low 6=high) in Kyrgyz Republic in 2009 to that in 2010?
Your response must be concise. 1. What is the ratio of the Rating (1=low 6=high) of Rwanda in 2009 to that in 2010?
Ensure brevity in your answer.  0.95. What is the ratio of the Rating (1=low 6=high) of Tanzania in 2009 to that in 2010?
Offer a terse response. 1.06. What is the ratio of the Rating (1=low 6=high) in East Asia (developing only) in 2009 to that in 2011?
Keep it short and to the point. 0.99. What is the ratio of the Rating (1=low 6=high) in Kyrgyz Republic in 2009 to that in 2011?
Make the answer very short. 1. What is the ratio of the Rating (1=low 6=high) of Rwanda in 2009 to that in 2011?
Give a very brief answer. 0.97. What is the ratio of the Rating (1=low 6=high) in Tanzania in 2009 to that in 2011?
Offer a very short reply. 1.06. What is the ratio of the Rating (1=low 6=high) in Rwanda in 2009 to that in 2012?
Keep it short and to the point. 0.97. What is the ratio of the Rating (1=low 6=high) of Tanzania in 2009 to that in 2012?
Make the answer very short. 1.06. What is the ratio of the Rating (1=low 6=high) of East Asia (developing only) in 2009 to that in 2013?
Provide a succinct answer. 1.01. What is the ratio of the Rating (1=low 6=high) in Kyrgyz Republic in 2009 to that in 2013?
Provide a succinct answer. 0.97. What is the ratio of the Rating (1=low 6=high) in Rwanda in 2009 to that in 2013?
Offer a very short reply. 0.97. What is the ratio of the Rating (1=low 6=high) of Tanzania in 2009 to that in 2013?
Your response must be concise. 1.03. What is the ratio of the Rating (1=low 6=high) of East Asia (developing only) in 2009 to that in 2014?
Ensure brevity in your answer.  1.01. What is the ratio of the Rating (1=low 6=high) of Rwanda in 2009 to that in 2014?
Offer a very short reply. 0.97. What is the ratio of the Rating (1=low 6=high) of Tanzania in 2009 to that in 2014?
Your answer should be compact. 1.03. What is the ratio of the Rating (1=low 6=high) in East Asia (developing only) in 2010 to that in 2011?
Keep it short and to the point. 1.01. What is the ratio of the Rating (1=low 6=high) in Rwanda in 2010 to that in 2011?
Give a very brief answer. 1.03. What is the ratio of the Rating (1=low 6=high) in Tanzania in 2010 to that in 2011?
Provide a succinct answer. 1. What is the ratio of the Rating (1=low 6=high) in East Asia (developing only) in 2010 to that in 2012?
Ensure brevity in your answer.  1.02. What is the ratio of the Rating (1=low 6=high) in Kyrgyz Republic in 2010 to that in 2012?
Your answer should be very brief. 0.97. What is the ratio of the Rating (1=low 6=high) in Rwanda in 2010 to that in 2012?
Make the answer very short. 1.03. What is the ratio of the Rating (1=low 6=high) in Tanzania in 2010 to that in 2012?
Make the answer very short. 1. What is the ratio of the Rating (1=low 6=high) of East Asia (developing only) in 2010 to that in 2013?
Your answer should be very brief. 1.03. What is the ratio of the Rating (1=low 6=high) of Rwanda in 2010 to that in 2013?
Make the answer very short. 1.03. What is the ratio of the Rating (1=low 6=high) of Tanzania in 2010 to that in 2013?
Your response must be concise. 0.97. What is the ratio of the Rating (1=low 6=high) of East Asia (developing only) in 2010 to that in 2014?
Provide a succinct answer. 1.03. What is the ratio of the Rating (1=low 6=high) of Rwanda in 2010 to that in 2014?
Provide a succinct answer. 1.03. What is the ratio of the Rating (1=low 6=high) in Tanzania in 2010 to that in 2014?
Provide a succinct answer. 0.97. What is the ratio of the Rating (1=low 6=high) in Rwanda in 2011 to that in 2012?
Provide a succinct answer. 1. What is the ratio of the Rating (1=low 6=high) in East Asia (developing only) in 2011 to that in 2013?
Your answer should be compact. 1.02. What is the ratio of the Rating (1=low 6=high) in Tanzania in 2011 to that in 2013?
Your response must be concise. 0.97. What is the ratio of the Rating (1=low 6=high) in East Asia (developing only) in 2011 to that in 2014?
Offer a very short reply. 1.02. What is the ratio of the Rating (1=low 6=high) in Tanzania in 2011 to that in 2014?
Your response must be concise. 0.97. What is the ratio of the Rating (1=low 6=high) in East Asia (developing only) in 2012 to that in 2013?
Provide a short and direct response. 1.01. What is the ratio of the Rating (1=low 6=high) of Kyrgyz Republic in 2012 to that in 2013?
Give a very brief answer. 1. What is the ratio of the Rating (1=low 6=high) of Tanzania in 2012 to that in 2013?
Your answer should be compact. 0.97. What is the ratio of the Rating (1=low 6=high) of East Asia (developing only) in 2012 to that in 2014?
Offer a terse response. 1.01. What is the ratio of the Rating (1=low 6=high) of Kyrgyz Republic in 2012 to that in 2014?
Provide a short and direct response. 0.97. What is the ratio of the Rating (1=low 6=high) in Tanzania in 2012 to that in 2014?
Make the answer very short. 0.97. What is the ratio of the Rating (1=low 6=high) of East Asia (developing only) in 2013 to that in 2014?
Give a very brief answer. 1. What is the ratio of the Rating (1=low 6=high) of Kyrgyz Republic in 2013 to that in 2014?
Provide a short and direct response. 0.97. What is the ratio of the Rating (1=low 6=high) of Rwanda in 2013 to that in 2014?
Make the answer very short. 1. What is the ratio of the Rating (1=low 6=high) in Tanzania in 2013 to that in 2014?
Make the answer very short. 1. What is the difference between the highest and the second highest Rating (1=low 6=high) in East Asia (developing only)?
Provide a short and direct response. 0.04. What is the difference between the highest and the second highest Rating (1=low 6=high) in Kyrgyz Republic?
Provide a short and direct response. 0.1. What is the difference between the highest and the lowest Rating (1=low 6=high) of East Asia (developing only)?
Your answer should be very brief. 0.18. What is the difference between the highest and the lowest Rating (1=low 6=high) in Rwanda?
Make the answer very short. 0.2. What is the difference between the highest and the lowest Rating (1=low 6=high) in Tanzania?
Provide a succinct answer. 0.4. 